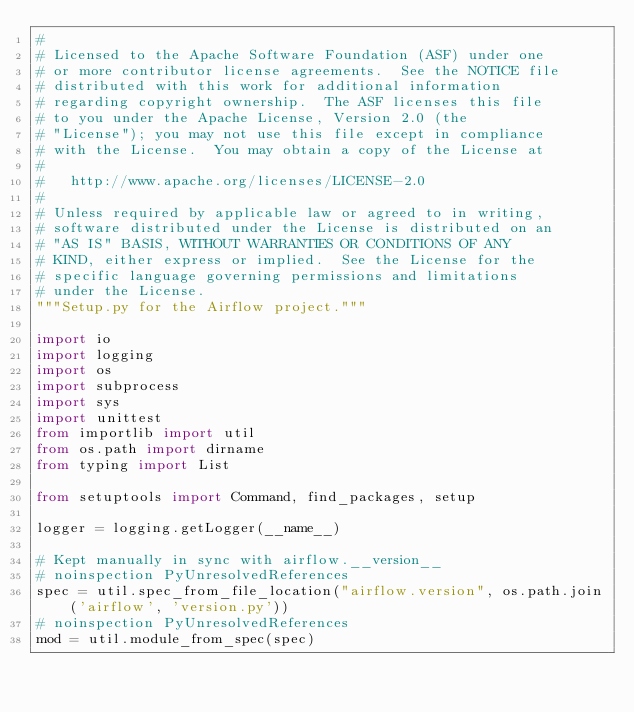<code> <loc_0><loc_0><loc_500><loc_500><_Python_>#
# Licensed to the Apache Software Foundation (ASF) under one
# or more contributor license agreements.  See the NOTICE file
# distributed with this work for additional information
# regarding copyright ownership.  The ASF licenses this file
# to you under the Apache License, Version 2.0 (the
# "License"); you may not use this file except in compliance
# with the License.  You may obtain a copy of the License at
#
#   http://www.apache.org/licenses/LICENSE-2.0
#
# Unless required by applicable law or agreed to in writing,
# software distributed under the License is distributed on an
# "AS IS" BASIS, WITHOUT WARRANTIES OR CONDITIONS OF ANY
# KIND, either express or implied.  See the License for the
# specific language governing permissions and limitations
# under the License.
"""Setup.py for the Airflow project."""

import io
import logging
import os
import subprocess
import sys
import unittest
from importlib import util
from os.path import dirname
from typing import List

from setuptools import Command, find_packages, setup

logger = logging.getLogger(__name__)

# Kept manually in sync with airflow.__version__
# noinspection PyUnresolvedReferences
spec = util.spec_from_file_location("airflow.version", os.path.join('airflow', 'version.py'))
# noinspection PyUnresolvedReferences
mod = util.module_from_spec(spec)</code> 